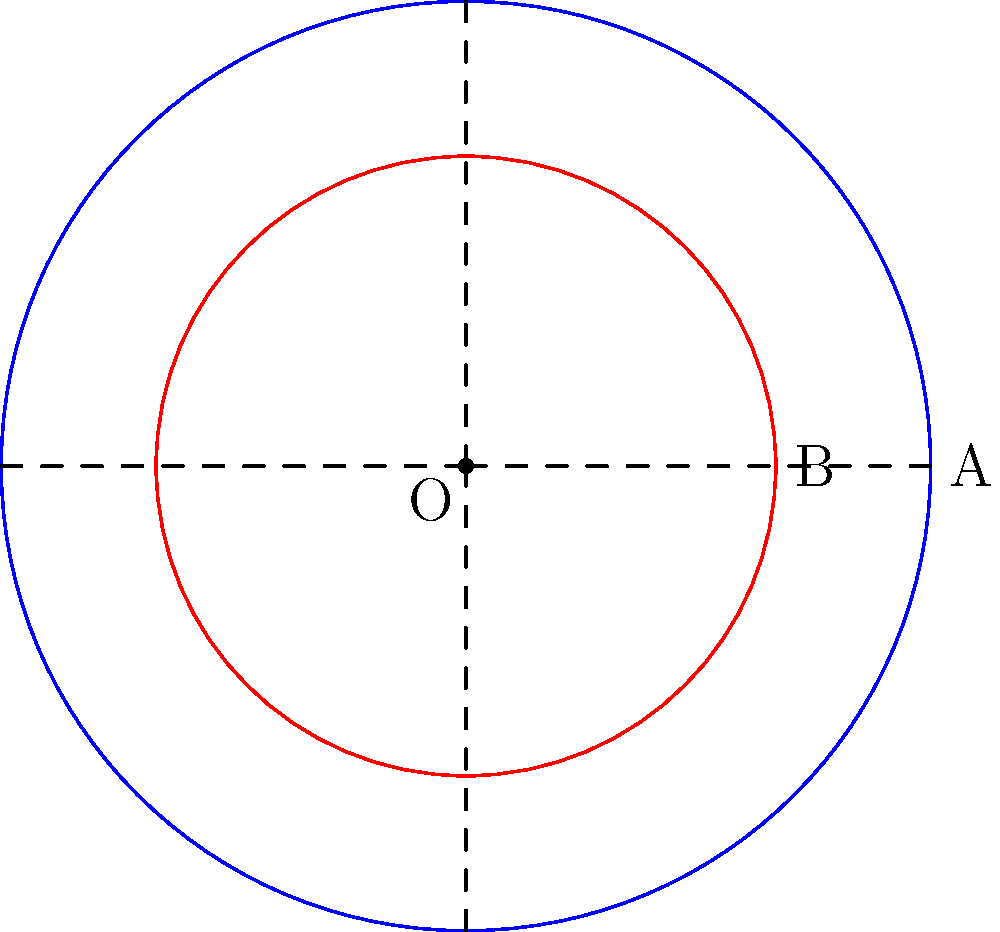In the context of the Battle of Austerlitz (1805), Napoleon's Grande Armée utilized a unique circular formation. The outer circle, representing cavalry, had a radius of 300 meters. The inner circle, consisting of infantry, had a radius of 200 meters. If we consider this formation as concentric circles, what is the area of the region between these two circles, where the artillery was positioned? Express your answer in square meters and relate it to a historical fact from the same era. Let's approach this step-by-step:

1) The area between two concentric circles is given by the formula:
   $$A = \pi(R^2 - r^2)$$
   where $R$ is the radius of the larger circle and $r$ is the radius of the smaller circle.

2) In this case:
   $R = 300$ meters (cavalry)
   $r = 200$ meters (infantry)

3) Substituting these values:
   $$A = \pi(300^2 - 200^2)$$

4) Simplify:
   $$A = \pi(90,000 - 40,000)$$
   $$A = \pi(50,000)$$

5) Calculate:
   $$A = 157,079.63...$$

6) Rounding to the nearest whole number:
   $$A \approx 157,080 \text{ square meters}$$

Historical context:
This area of approximately 157,080 square meters is interestingly close to the size of the Champ de Mars in Paris, which measures about 150,000 square meters. The Champ de Mars was the site of the Fête de la Fédération in 1790, a massive feast celebrating the first anniversary of the storming of the Bastille. This event, occurring just 15 years before the Battle of Austerlitz, was a pivotal moment in the French Revolution, which greatly influenced Napoleon's rise to power.
Answer: 157,080 square meters, comparable to the Champ de Mars in Paris. 